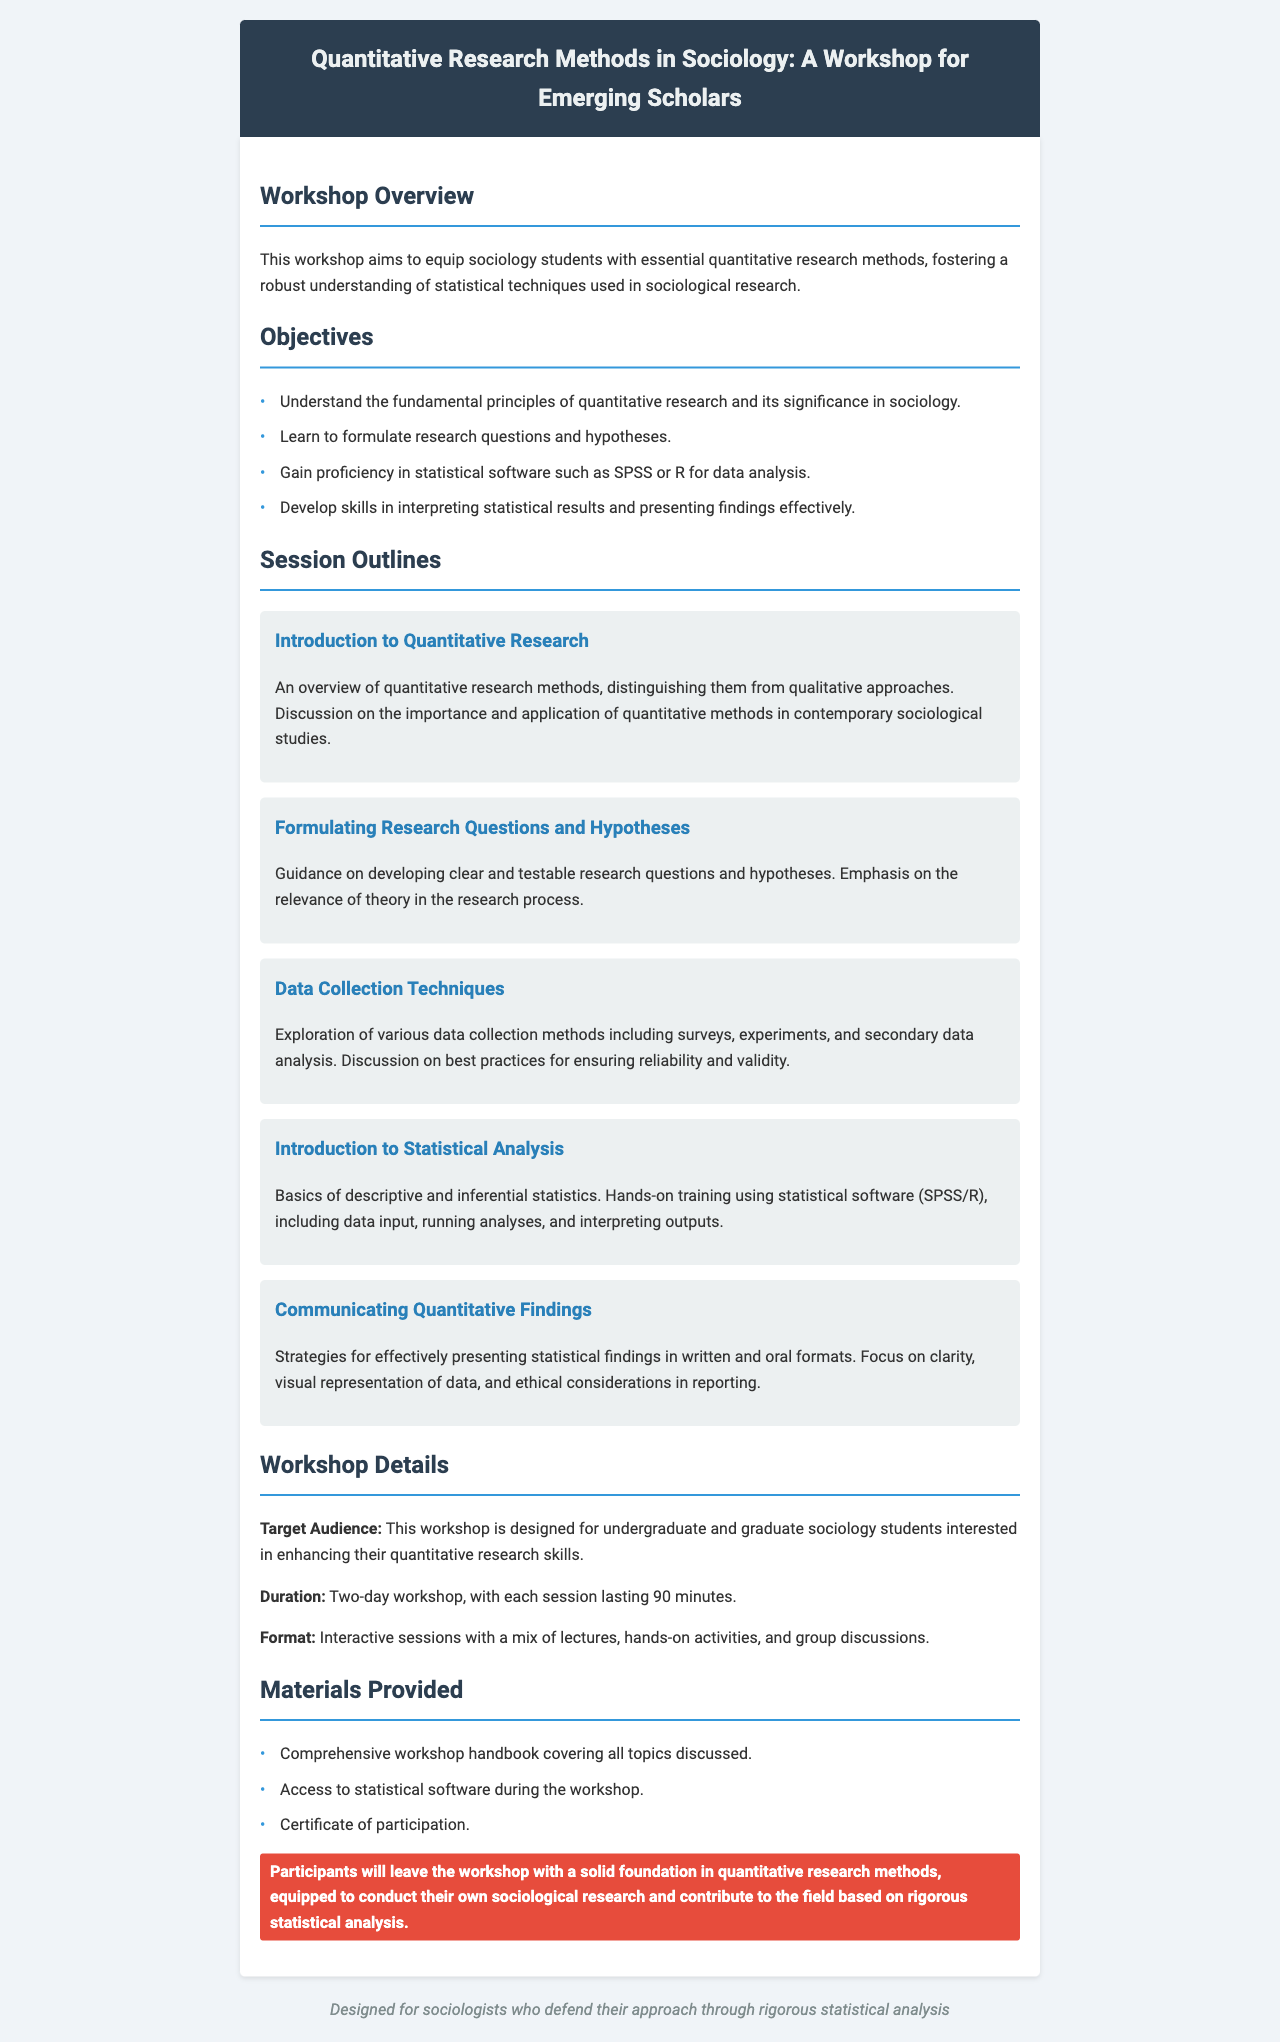What is the title of the workshop? The title of the workshop is mentioned prominently at the top of the document.
Answer: Quantitative Research Methods in Sociology: A Workshop for Emerging Scholars What is the target audience of the workshop? The document specifies the target audience for the workshop in the section titled "Workshop Details."
Answer: Undergraduate and graduate sociology students How long is each session of the workshop? The document indicates the length of each session in the "Workshop Details" section.
Answer: 90 minutes What statistical software will be used in the workshop? The document mentions the statistical software in the session outline about statistical analysis.
Answer: SPSS or R How many sessions are covered in the workshop? The document lists the different sessions included in the workshop.
Answer: Five What materials are provided to participants? The document outlines the materials provided in the "Materials Provided" section.
Answer: Comprehensive workshop handbook, access to statistical software, certificate of participation Why is quantitative research significant in sociology? The document provides insight into the importance of quantitative research in the workshop overview.
Answer: It fosters a robust understanding of statistical techniques used in sociological research What will participants leave with after the workshop? The document highlights the outcomes for participants at the end of the workshop in the highlight section.
Answer: A solid foundation in quantitative research methods 